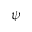<formula> <loc_0><loc_0><loc_500><loc_500>\psi</formula> 